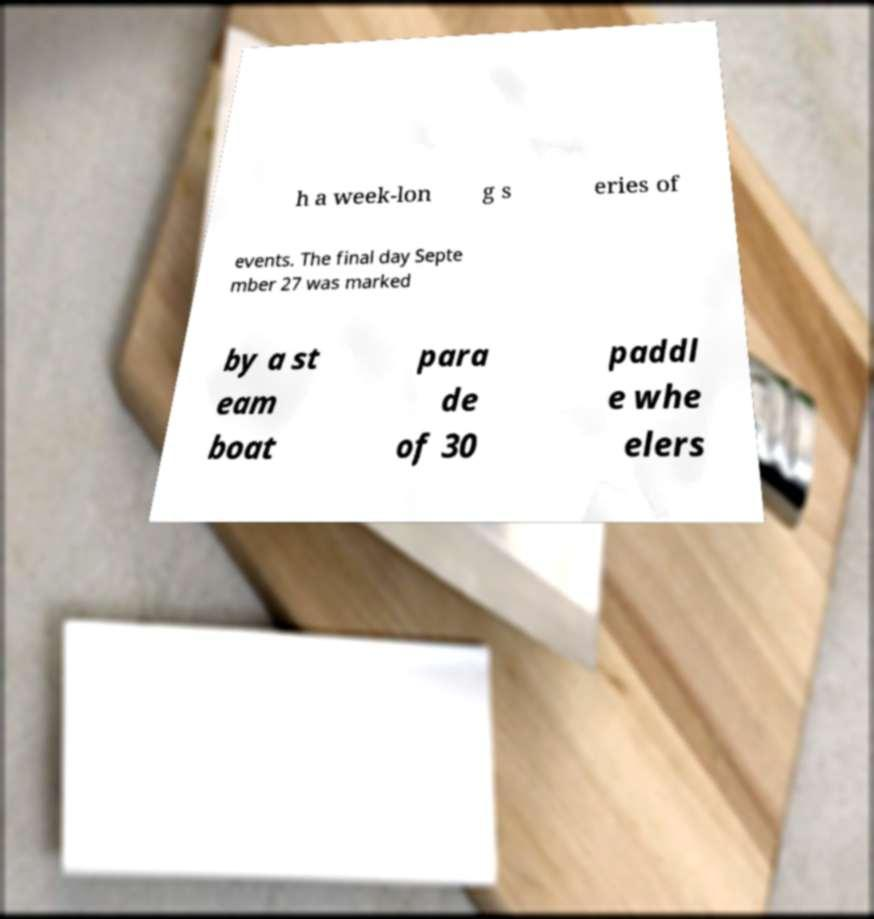Could you extract and type out the text from this image? h a week-lon g s eries of events. The final day Septe mber 27 was marked by a st eam boat para de of 30 paddl e whe elers 